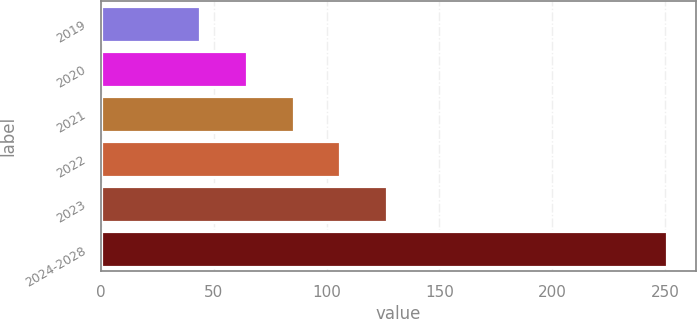Convert chart. <chart><loc_0><loc_0><loc_500><loc_500><bar_chart><fcel>2019<fcel>2020<fcel>2021<fcel>2022<fcel>2023<fcel>2024-2028<nl><fcel>44<fcel>64.7<fcel>85.4<fcel>106.1<fcel>126.8<fcel>251<nl></chart> 